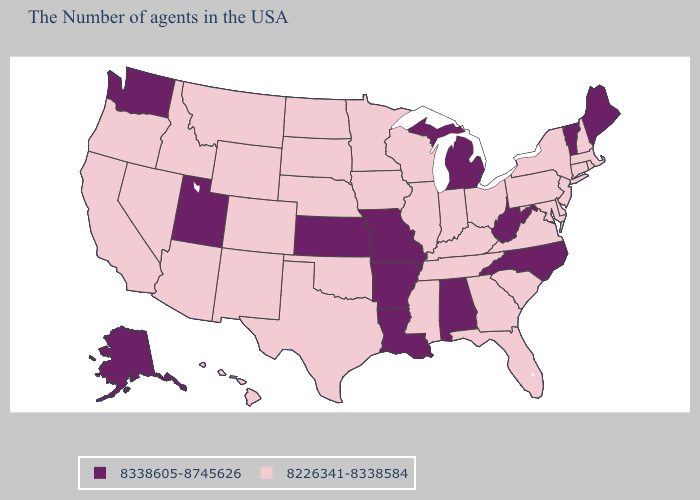Does Kentucky have the highest value in the South?
Be succinct. No. What is the lowest value in the USA?
Write a very short answer. 8226341-8338584. What is the value of Georgia?
Answer briefly. 8226341-8338584. What is the value of Alabama?
Quick response, please. 8338605-8745626. Name the states that have a value in the range 8338605-8745626?
Be succinct. Maine, Vermont, North Carolina, West Virginia, Michigan, Alabama, Louisiana, Missouri, Arkansas, Kansas, Utah, Washington, Alaska. What is the value of Iowa?
Concise answer only. 8226341-8338584. Does Connecticut have a lower value than Hawaii?
Keep it brief. No. What is the value of South Carolina?
Answer briefly. 8226341-8338584. Which states have the lowest value in the South?
Give a very brief answer. Delaware, Maryland, Virginia, South Carolina, Florida, Georgia, Kentucky, Tennessee, Mississippi, Oklahoma, Texas. How many symbols are there in the legend?
Give a very brief answer. 2. Does Maryland have the lowest value in the USA?
Be succinct. Yes. Does Missouri have the lowest value in the USA?
Concise answer only. No. Among the states that border Maine , which have the lowest value?
Quick response, please. New Hampshire. What is the value of Alaska?
Concise answer only. 8338605-8745626. 